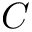Convert formula to latex. <formula><loc_0><loc_0><loc_500><loc_500>C</formula> 